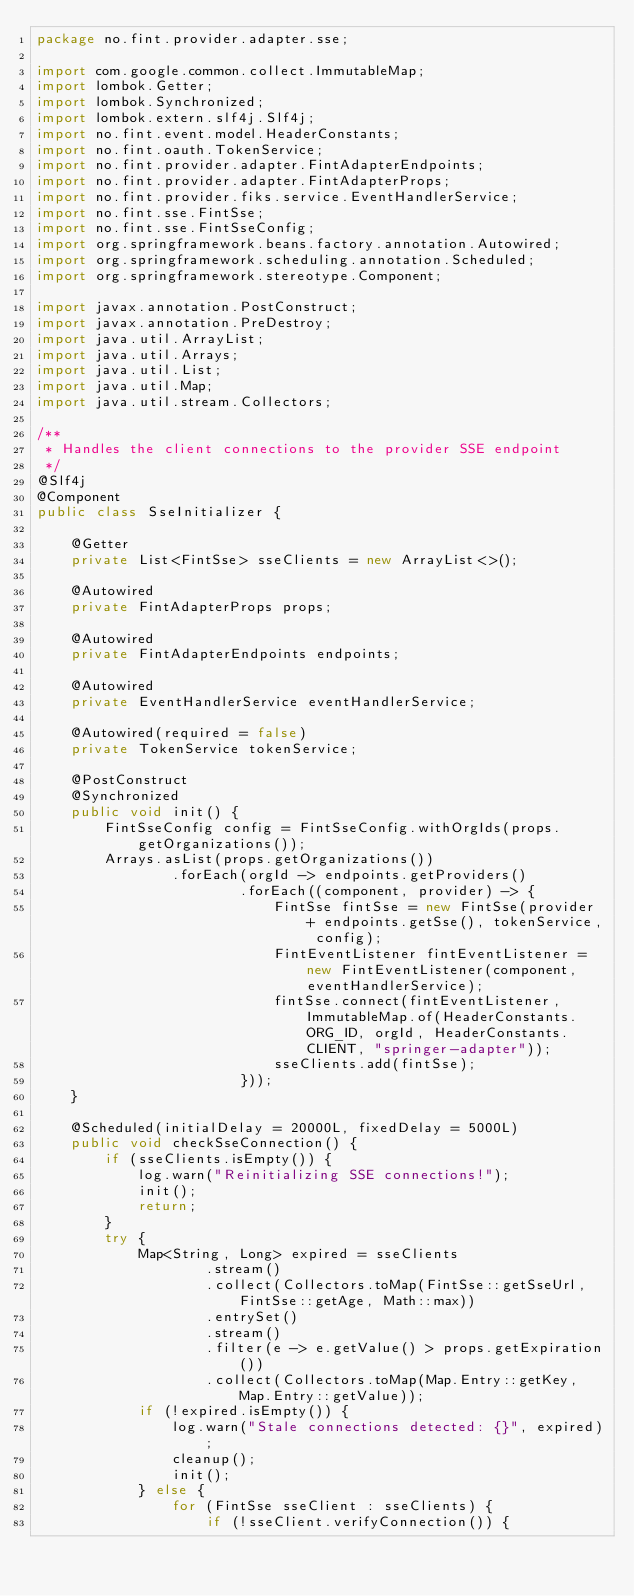<code> <loc_0><loc_0><loc_500><loc_500><_Java_>package no.fint.provider.adapter.sse;

import com.google.common.collect.ImmutableMap;
import lombok.Getter;
import lombok.Synchronized;
import lombok.extern.slf4j.Slf4j;
import no.fint.event.model.HeaderConstants;
import no.fint.oauth.TokenService;
import no.fint.provider.adapter.FintAdapterEndpoints;
import no.fint.provider.adapter.FintAdapterProps;
import no.fint.provider.fiks.service.EventHandlerService;
import no.fint.sse.FintSse;
import no.fint.sse.FintSseConfig;
import org.springframework.beans.factory.annotation.Autowired;
import org.springframework.scheduling.annotation.Scheduled;
import org.springframework.stereotype.Component;

import javax.annotation.PostConstruct;
import javax.annotation.PreDestroy;
import java.util.ArrayList;
import java.util.Arrays;
import java.util.List;
import java.util.Map;
import java.util.stream.Collectors;

/**
 * Handles the client connections to the provider SSE endpoint
 */
@Slf4j
@Component
public class SseInitializer {

    @Getter
    private List<FintSse> sseClients = new ArrayList<>();

    @Autowired
    private FintAdapterProps props;

    @Autowired
    private FintAdapterEndpoints endpoints;

    @Autowired
    private EventHandlerService eventHandlerService;

    @Autowired(required = false)
    private TokenService tokenService;

    @PostConstruct
    @Synchronized
    public void init() {
        FintSseConfig config = FintSseConfig.withOrgIds(props.getOrganizations());
        Arrays.asList(props.getOrganizations())
                .forEach(orgId -> endpoints.getProviders()
                        .forEach((component, provider) -> {
                            FintSse fintSse = new FintSse(provider + endpoints.getSse(), tokenService, config);
                            FintEventListener fintEventListener = new FintEventListener(component, eventHandlerService);
                            fintSse.connect(fintEventListener, ImmutableMap.of(HeaderConstants.ORG_ID, orgId, HeaderConstants.CLIENT, "springer-adapter"));
                            sseClients.add(fintSse);
                        }));
    }

    @Scheduled(initialDelay = 20000L, fixedDelay = 5000L)
    public void checkSseConnection() {
        if (sseClients.isEmpty()) {
            log.warn("Reinitializing SSE connections!");
            init();
            return;
        }
        try {
            Map<String, Long> expired = sseClients
                    .stream()
                    .collect(Collectors.toMap(FintSse::getSseUrl, FintSse::getAge, Math::max))
                    .entrySet()
                    .stream()
                    .filter(e -> e.getValue() > props.getExpiration())
                    .collect(Collectors.toMap(Map.Entry::getKey, Map.Entry::getValue));
            if (!expired.isEmpty()) {
                log.warn("Stale connections detected: {}", expired);
                cleanup();
                init();
            } else {
                for (FintSse sseClient : sseClients) {
                    if (!sseClient.verifyConnection()) {</code> 